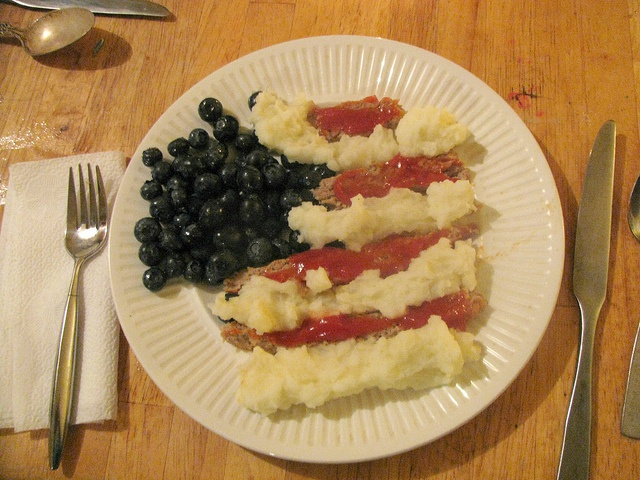Describe the objects in this image and their specific colors. I can see dining table in olive and tan tones, knife in black, olive, and gray tones, fork in black, olive, tan, and gray tones, spoon in black, tan, gray, and olive tones, and knife in black, gray, and olive tones in this image. 